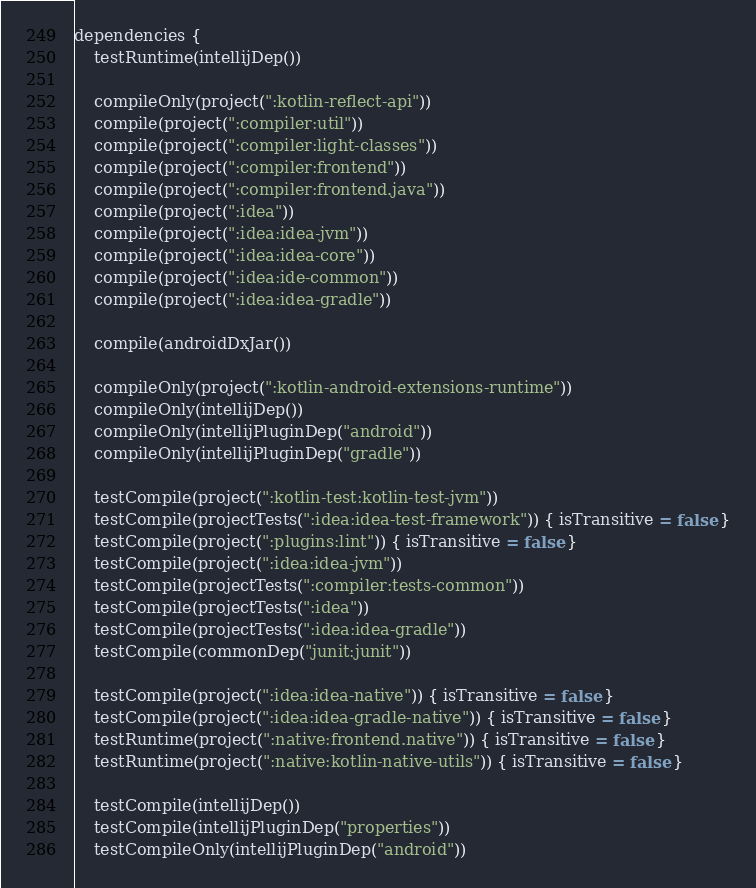<code> <loc_0><loc_0><loc_500><loc_500><_Kotlin_>
dependencies {
    testRuntime(intellijDep())

    compileOnly(project(":kotlin-reflect-api"))
    compile(project(":compiler:util"))
    compile(project(":compiler:light-classes"))
    compile(project(":compiler:frontend"))
    compile(project(":compiler:frontend.java"))
    compile(project(":idea"))
    compile(project(":idea:idea-jvm"))
    compile(project(":idea:idea-core"))
    compile(project(":idea:ide-common"))
    compile(project(":idea:idea-gradle"))

    compile(androidDxJar())

    compileOnly(project(":kotlin-android-extensions-runtime"))
    compileOnly(intellijDep())
    compileOnly(intellijPluginDep("android"))
    compileOnly(intellijPluginDep("gradle"))

    testCompile(project(":kotlin-test:kotlin-test-jvm"))
    testCompile(projectTests(":idea:idea-test-framework")) { isTransitive = false }
    testCompile(project(":plugins:lint")) { isTransitive = false }
    testCompile(project(":idea:idea-jvm"))
    testCompile(projectTests(":compiler:tests-common"))
    testCompile(projectTests(":idea"))
    testCompile(projectTests(":idea:idea-gradle"))
    testCompile(commonDep("junit:junit"))

    testCompile(project(":idea:idea-native")) { isTransitive = false }
    testCompile(project(":idea:idea-gradle-native")) { isTransitive = false }
    testRuntime(project(":native:frontend.native")) { isTransitive = false }
    testRuntime(project(":native:kotlin-native-utils")) { isTransitive = false }

    testCompile(intellijDep())
    testCompile(intellijPluginDep("properties"))
    testCompileOnly(intellijPluginDep("android"))
</code> 